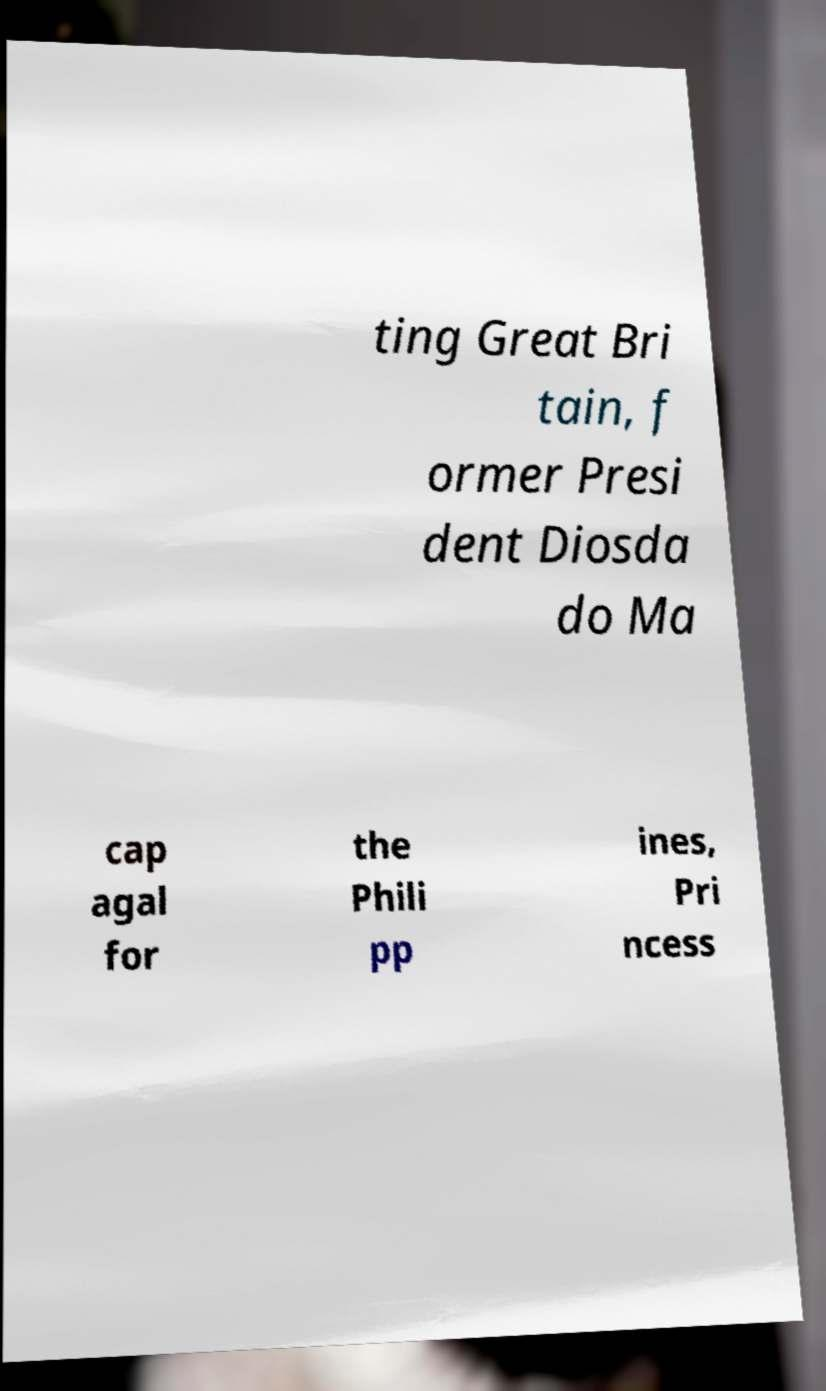Please identify and transcribe the text found in this image. ting Great Bri tain, f ormer Presi dent Diosda do Ma cap agal for the Phili pp ines, Pri ncess 